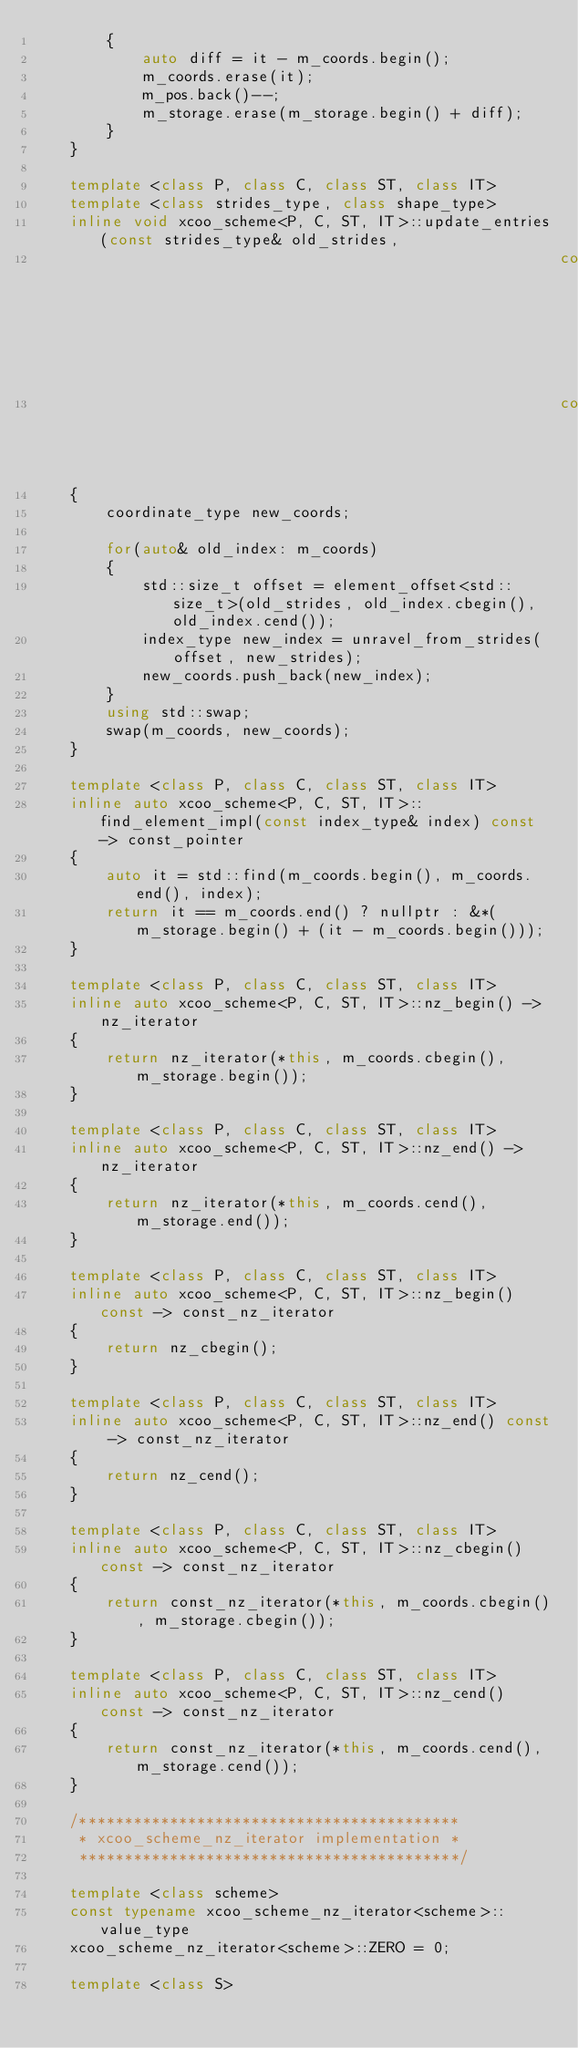<code> <loc_0><loc_0><loc_500><loc_500><_C++_>        {
            auto diff = it - m_coords.begin();
            m_coords.erase(it);
            m_pos.back()--;
            m_storage.erase(m_storage.begin() + diff);
        }
    }

    template <class P, class C, class ST, class IT>
    template <class strides_type, class shape_type>
    inline void xcoo_scheme<P, C, ST, IT>::update_entries(const strides_type& old_strides,
                                                          const strides_type& new_strides,
                                                          const shape_type&)
    {
        coordinate_type new_coords;

        for(auto& old_index: m_coords)
        {
            std::size_t offset = element_offset<std::size_t>(old_strides, old_index.cbegin(), old_index.cend());
            index_type new_index = unravel_from_strides(offset, new_strides);
            new_coords.push_back(new_index);
        }
        using std::swap;
        swap(m_coords, new_coords);
    }

    template <class P, class C, class ST, class IT>
    inline auto xcoo_scheme<P, C, ST, IT>::find_element_impl(const index_type& index) const -> const_pointer
    {
        auto it = std::find(m_coords.begin(), m_coords.end(), index);
        return it == m_coords.end() ? nullptr : &*(m_storage.begin() + (it - m_coords.begin()));
    }

    template <class P, class C, class ST, class IT>
    inline auto xcoo_scheme<P, C, ST, IT>::nz_begin() -> nz_iterator
    {
        return nz_iterator(*this, m_coords.cbegin(), m_storage.begin());
    }

    template <class P, class C, class ST, class IT>
    inline auto xcoo_scheme<P, C, ST, IT>::nz_end() -> nz_iterator
    {
        return nz_iterator(*this, m_coords.cend(), m_storage.end());
    }

    template <class P, class C, class ST, class IT>
    inline auto xcoo_scheme<P, C, ST, IT>::nz_begin() const -> const_nz_iterator
    {
        return nz_cbegin();
    }

    template <class P, class C, class ST, class IT>
    inline auto xcoo_scheme<P, C, ST, IT>::nz_end() const -> const_nz_iterator
    {
        return nz_cend();
    }

    template <class P, class C, class ST, class IT>
    inline auto xcoo_scheme<P, C, ST, IT>::nz_cbegin() const -> const_nz_iterator
    {
        return const_nz_iterator(*this, m_coords.cbegin(), m_storage.cbegin());
    }

    template <class P, class C, class ST, class IT>
    inline auto xcoo_scheme<P, C, ST, IT>::nz_cend() const -> const_nz_iterator
    {
        return const_nz_iterator(*this, m_coords.cend(), m_storage.cend());
    }

    /******************************************
     * xcoo_scheme_nz_iterator implementation *
     ******************************************/

    template <class scheme>
    const typename xcoo_scheme_nz_iterator<scheme>::value_type
    xcoo_scheme_nz_iterator<scheme>::ZERO = 0;

    template <class S></code> 